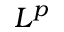Convert formula to latex. <formula><loc_0><loc_0><loc_500><loc_500>L ^ { p }</formula> 